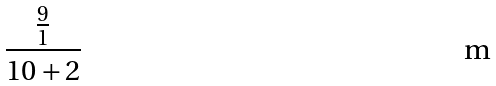<formula> <loc_0><loc_0><loc_500><loc_500>\frac { \frac { 9 } { 1 } } { 1 0 + 2 }</formula> 